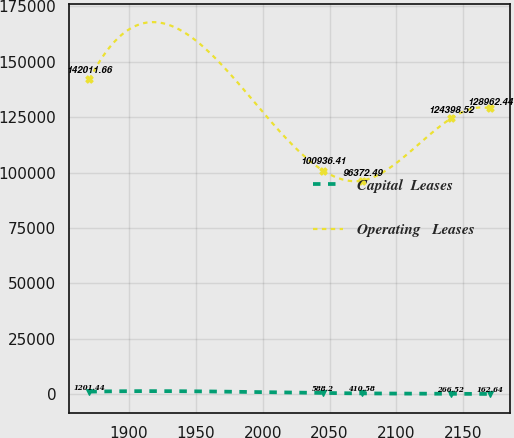Convert chart. <chart><loc_0><loc_0><loc_500><loc_500><line_chart><ecel><fcel>Capital  Leases<fcel>Operating   Leases<nl><fcel>1870.38<fcel>1201.44<fcel>142012<nl><fcel>2045.14<fcel>588.2<fcel>100936<nl><fcel>2074.3<fcel>410.58<fcel>96372.5<nl><fcel>2140.74<fcel>266.52<fcel>124399<nl><fcel>2169.9<fcel>162.64<fcel>128962<nl></chart> 